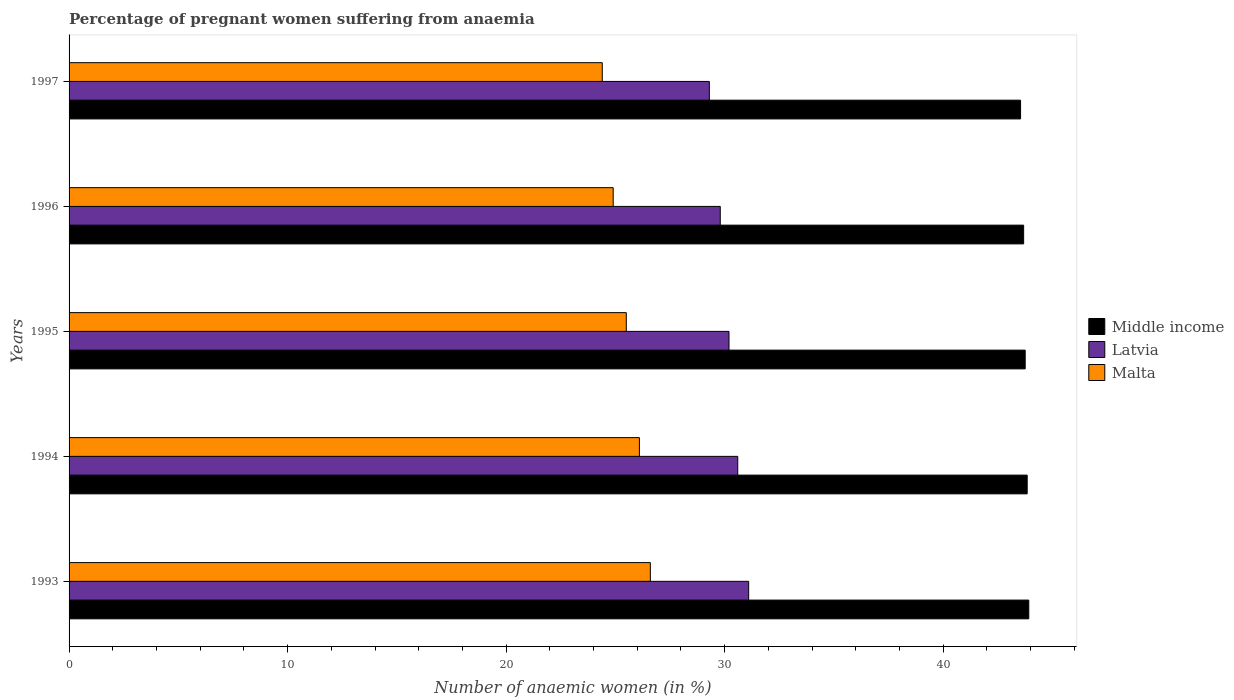How many groups of bars are there?
Ensure brevity in your answer.  5. Are the number of bars per tick equal to the number of legend labels?
Offer a terse response. Yes. How many bars are there on the 3rd tick from the bottom?
Provide a short and direct response. 3. What is the label of the 3rd group of bars from the top?
Your response must be concise. 1995. In how many cases, is the number of bars for a given year not equal to the number of legend labels?
Make the answer very short. 0. What is the number of anaemic women in Malta in 1997?
Offer a terse response. 24.4. Across all years, what is the maximum number of anaemic women in Malta?
Your response must be concise. 26.6. Across all years, what is the minimum number of anaemic women in Latvia?
Your answer should be very brief. 29.3. In which year was the number of anaemic women in Malta maximum?
Provide a short and direct response. 1993. In which year was the number of anaemic women in Malta minimum?
Provide a short and direct response. 1997. What is the total number of anaemic women in Latvia in the graph?
Your response must be concise. 151. What is the difference between the number of anaemic women in Malta in 1993 and that in 1997?
Offer a very short reply. 2.2. What is the difference between the number of anaemic women in Malta in 1996 and the number of anaemic women in Latvia in 1997?
Your answer should be very brief. -4.4. In the year 1997, what is the difference between the number of anaemic women in Latvia and number of anaemic women in Middle income?
Ensure brevity in your answer.  -14.24. What is the ratio of the number of anaemic women in Middle income in 1995 to that in 1996?
Offer a very short reply. 1. Is the number of anaemic women in Latvia in 1994 less than that in 1997?
Ensure brevity in your answer.  No. What is the difference between the highest and the lowest number of anaemic women in Latvia?
Your answer should be very brief. 1.8. What does the 2nd bar from the top in 1993 represents?
Give a very brief answer. Latvia. What does the 2nd bar from the bottom in 1994 represents?
Keep it short and to the point. Latvia. Is it the case that in every year, the sum of the number of anaemic women in Middle income and number of anaemic women in Latvia is greater than the number of anaemic women in Malta?
Give a very brief answer. Yes. How many bars are there?
Your response must be concise. 15. Are all the bars in the graph horizontal?
Provide a succinct answer. Yes. How many years are there in the graph?
Your answer should be compact. 5. Are the values on the major ticks of X-axis written in scientific E-notation?
Ensure brevity in your answer.  No. How are the legend labels stacked?
Provide a succinct answer. Vertical. What is the title of the graph?
Keep it short and to the point. Percentage of pregnant women suffering from anaemia. What is the label or title of the X-axis?
Offer a very short reply. Number of anaemic women (in %). What is the Number of anaemic women (in %) in Middle income in 1993?
Your response must be concise. 43.92. What is the Number of anaemic women (in %) of Latvia in 1993?
Provide a short and direct response. 31.1. What is the Number of anaemic women (in %) of Malta in 1993?
Make the answer very short. 26.6. What is the Number of anaemic women (in %) in Middle income in 1994?
Give a very brief answer. 43.85. What is the Number of anaemic women (in %) in Latvia in 1994?
Your response must be concise. 30.6. What is the Number of anaemic women (in %) in Malta in 1994?
Offer a very short reply. 26.1. What is the Number of anaemic women (in %) in Middle income in 1995?
Provide a short and direct response. 43.75. What is the Number of anaemic women (in %) in Latvia in 1995?
Your answer should be compact. 30.2. What is the Number of anaemic women (in %) of Malta in 1995?
Your answer should be very brief. 25.5. What is the Number of anaemic women (in %) in Middle income in 1996?
Offer a very short reply. 43.68. What is the Number of anaemic women (in %) in Latvia in 1996?
Ensure brevity in your answer.  29.8. What is the Number of anaemic women (in %) in Malta in 1996?
Your answer should be very brief. 24.9. What is the Number of anaemic women (in %) in Middle income in 1997?
Ensure brevity in your answer.  43.54. What is the Number of anaemic women (in %) in Latvia in 1997?
Ensure brevity in your answer.  29.3. What is the Number of anaemic women (in %) of Malta in 1997?
Your response must be concise. 24.4. Across all years, what is the maximum Number of anaemic women (in %) of Middle income?
Your response must be concise. 43.92. Across all years, what is the maximum Number of anaemic women (in %) in Latvia?
Your answer should be compact. 31.1. Across all years, what is the maximum Number of anaemic women (in %) of Malta?
Give a very brief answer. 26.6. Across all years, what is the minimum Number of anaemic women (in %) of Middle income?
Provide a short and direct response. 43.54. Across all years, what is the minimum Number of anaemic women (in %) of Latvia?
Your answer should be compact. 29.3. Across all years, what is the minimum Number of anaemic women (in %) of Malta?
Your answer should be compact. 24.4. What is the total Number of anaemic women (in %) in Middle income in the graph?
Your response must be concise. 218.74. What is the total Number of anaemic women (in %) of Latvia in the graph?
Offer a very short reply. 151. What is the total Number of anaemic women (in %) in Malta in the graph?
Keep it short and to the point. 127.5. What is the difference between the Number of anaemic women (in %) of Middle income in 1993 and that in 1994?
Your answer should be compact. 0.07. What is the difference between the Number of anaemic women (in %) in Latvia in 1993 and that in 1994?
Your answer should be compact. 0.5. What is the difference between the Number of anaemic women (in %) in Malta in 1993 and that in 1994?
Provide a succinct answer. 0.5. What is the difference between the Number of anaemic women (in %) in Middle income in 1993 and that in 1995?
Your answer should be compact. 0.17. What is the difference between the Number of anaemic women (in %) in Latvia in 1993 and that in 1995?
Give a very brief answer. 0.9. What is the difference between the Number of anaemic women (in %) in Middle income in 1993 and that in 1996?
Your answer should be very brief. 0.24. What is the difference between the Number of anaemic women (in %) in Malta in 1993 and that in 1996?
Give a very brief answer. 1.7. What is the difference between the Number of anaemic women (in %) in Middle income in 1993 and that in 1997?
Make the answer very short. 0.38. What is the difference between the Number of anaemic women (in %) in Latvia in 1993 and that in 1997?
Make the answer very short. 1.8. What is the difference between the Number of anaemic women (in %) in Middle income in 1994 and that in 1995?
Provide a succinct answer. 0.09. What is the difference between the Number of anaemic women (in %) in Middle income in 1994 and that in 1996?
Provide a succinct answer. 0.16. What is the difference between the Number of anaemic women (in %) of Malta in 1994 and that in 1996?
Your response must be concise. 1.2. What is the difference between the Number of anaemic women (in %) in Middle income in 1994 and that in 1997?
Give a very brief answer. 0.3. What is the difference between the Number of anaemic women (in %) of Latvia in 1994 and that in 1997?
Your answer should be compact. 1.3. What is the difference between the Number of anaemic women (in %) of Middle income in 1995 and that in 1996?
Your response must be concise. 0.07. What is the difference between the Number of anaemic women (in %) in Latvia in 1995 and that in 1996?
Offer a very short reply. 0.4. What is the difference between the Number of anaemic women (in %) in Malta in 1995 and that in 1996?
Your answer should be compact. 0.6. What is the difference between the Number of anaemic women (in %) in Middle income in 1995 and that in 1997?
Ensure brevity in your answer.  0.21. What is the difference between the Number of anaemic women (in %) in Latvia in 1995 and that in 1997?
Provide a short and direct response. 0.9. What is the difference between the Number of anaemic women (in %) of Malta in 1995 and that in 1997?
Ensure brevity in your answer.  1.1. What is the difference between the Number of anaemic women (in %) in Middle income in 1996 and that in 1997?
Provide a succinct answer. 0.14. What is the difference between the Number of anaemic women (in %) in Latvia in 1996 and that in 1997?
Provide a short and direct response. 0.5. What is the difference between the Number of anaemic women (in %) in Malta in 1996 and that in 1997?
Your response must be concise. 0.5. What is the difference between the Number of anaemic women (in %) in Middle income in 1993 and the Number of anaemic women (in %) in Latvia in 1994?
Ensure brevity in your answer.  13.32. What is the difference between the Number of anaemic women (in %) of Middle income in 1993 and the Number of anaemic women (in %) of Malta in 1994?
Your answer should be very brief. 17.82. What is the difference between the Number of anaemic women (in %) in Latvia in 1993 and the Number of anaemic women (in %) in Malta in 1994?
Provide a succinct answer. 5. What is the difference between the Number of anaemic women (in %) in Middle income in 1993 and the Number of anaemic women (in %) in Latvia in 1995?
Offer a terse response. 13.72. What is the difference between the Number of anaemic women (in %) of Middle income in 1993 and the Number of anaemic women (in %) of Malta in 1995?
Your answer should be compact. 18.42. What is the difference between the Number of anaemic women (in %) of Middle income in 1993 and the Number of anaemic women (in %) of Latvia in 1996?
Offer a terse response. 14.12. What is the difference between the Number of anaemic women (in %) of Middle income in 1993 and the Number of anaemic women (in %) of Malta in 1996?
Provide a succinct answer. 19.02. What is the difference between the Number of anaemic women (in %) of Latvia in 1993 and the Number of anaemic women (in %) of Malta in 1996?
Provide a short and direct response. 6.2. What is the difference between the Number of anaemic women (in %) of Middle income in 1993 and the Number of anaemic women (in %) of Latvia in 1997?
Provide a succinct answer. 14.62. What is the difference between the Number of anaemic women (in %) of Middle income in 1993 and the Number of anaemic women (in %) of Malta in 1997?
Provide a succinct answer. 19.52. What is the difference between the Number of anaemic women (in %) of Middle income in 1994 and the Number of anaemic women (in %) of Latvia in 1995?
Offer a terse response. 13.65. What is the difference between the Number of anaemic women (in %) of Middle income in 1994 and the Number of anaemic women (in %) of Malta in 1995?
Offer a very short reply. 18.35. What is the difference between the Number of anaemic women (in %) in Latvia in 1994 and the Number of anaemic women (in %) in Malta in 1995?
Offer a very short reply. 5.1. What is the difference between the Number of anaemic women (in %) in Middle income in 1994 and the Number of anaemic women (in %) in Latvia in 1996?
Your answer should be compact. 14.05. What is the difference between the Number of anaemic women (in %) in Middle income in 1994 and the Number of anaemic women (in %) in Malta in 1996?
Provide a succinct answer. 18.95. What is the difference between the Number of anaemic women (in %) in Latvia in 1994 and the Number of anaemic women (in %) in Malta in 1996?
Provide a succinct answer. 5.7. What is the difference between the Number of anaemic women (in %) of Middle income in 1994 and the Number of anaemic women (in %) of Latvia in 1997?
Keep it short and to the point. 14.55. What is the difference between the Number of anaemic women (in %) of Middle income in 1994 and the Number of anaemic women (in %) of Malta in 1997?
Make the answer very short. 19.45. What is the difference between the Number of anaemic women (in %) in Middle income in 1995 and the Number of anaemic women (in %) in Latvia in 1996?
Make the answer very short. 13.95. What is the difference between the Number of anaemic women (in %) in Middle income in 1995 and the Number of anaemic women (in %) in Malta in 1996?
Give a very brief answer. 18.85. What is the difference between the Number of anaemic women (in %) in Middle income in 1995 and the Number of anaemic women (in %) in Latvia in 1997?
Your answer should be compact. 14.45. What is the difference between the Number of anaemic women (in %) in Middle income in 1995 and the Number of anaemic women (in %) in Malta in 1997?
Your answer should be very brief. 19.35. What is the difference between the Number of anaemic women (in %) in Latvia in 1995 and the Number of anaemic women (in %) in Malta in 1997?
Provide a short and direct response. 5.8. What is the difference between the Number of anaemic women (in %) of Middle income in 1996 and the Number of anaemic women (in %) of Latvia in 1997?
Make the answer very short. 14.38. What is the difference between the Number of anaemic women (in %) of Middle income in 1996 and the Number of anaemic women (in %) of Malta in 1997?
Give a very brief answer. 19.28. What is the average Number of anaemic women (in %) of Middle income per year?
Offer a terse response. 43.75. What is the average Number of anaemic women (in %) of Latvia per year?
Your answer should be compact. 30.2. What is the average Number of anaemic women (in %) in Malta per year?
Offer a terse response. 25.5. In the year 1993, what is the difference between the Number of anaemic women (in %) of Middle income and Number of anaemic women (in %) of Latvia?
Offer a very short reply. 12.82. In the year 1993, what is the difference between the Number of anaemic women (in %) in Middle income and Number of anaemic women (in %) in Malta?
Provide a succinct answer. 17.32. In the year 1994, what is the difference between the Number of anaemic women (in %) of Middle income and Number of anaemic women (in %) of Latvia?
Make the answer very short. 13.25. In the year 1994, what is the difference between the Number of anaemic women (in %) of Middle income and Number of anaemic women (in %) of Malta?
Provide a short and direct response. 17.75. In the year 1994, what is the difference between the Number of anaemic women (in %) of Latvia and Number of anaemic women (in %) of Malta?
Your response must be concise. 4.5. In the year 1995, what is the difference between the Number of anaemic women (in %) of Middle income and Number of anaemic women (in %) of Latvia?
Your answer should be compact. 13.55. In the year 1995, what is the difference between the Number of anaemic women (in %) of Middle income and Number of anaemic women (in %) of Malta?
Keep it short and to the point. 18.25. In the year 1995, what is the difference between the Number of anaemic women (in %) in Latvia and Number of anaemic women (in %) in Malta?
Your response must be concise. 4.7. In the year 1996, what is the difference between the Number of anaemic women (in %) of Middle income and Number of anaemic women (in %) of Latvia?
Provide a succinct answer. 13.88. In the year 1996, what is the difference between the Number of anaemic women (in %) in Middle income and Number of anaemic women (in %) in Malta?
Your response must be concise. 18.78. In the year 1996, what is the difference between the Number of anaemic women (in %) in Latvia and Number of anaemic women (in %) in Malta?
Make the answer very short. 4.9. In the year 1997, what is the difference between the Number of anaemic women (in %) in Middle income and Number of anaemic women (in %) in Latvia?
Provide a short and direct response. 14.24. In the year 1997, what is the difference between the Number of anaemic women (in %) of Middle income and Number of anaemic women (in %) of Malta?
Ensure brevity in your answer.  19.14. What is the ratio of the Number of anaemic women (in %) in Latvia in 1993 to that in 1994?
Make the answer very short. 1.02. What is the ratio of the Number of anaemic women (in %) in Malta in 1993 to that in 1994?
Give a very brief answer. 1.02. What is the ratio of the Number of anaemic women (in %) in Middle income in 1993 to that in 1995?
Ensure brevity in your answer.  1. What is the ratio of the Number of anaemic women (in %) of Latvia in 1993 to that in 1995?
Give a very brief answer. 1.03. What is the ratio of the Number of anaemic women (in %) of Malta in 1993 to that in 1995?
Your answer should be very brief. 1.04. What is the ratio of the Number of anaemic women (in %) of Middle income in 1993 to that in 1996?
Keep it short and to the point. 1.01. What is the ratio of the Number of anaemic women (in %) in Latvia in 1993 to that in 1996?
Offer a very short reply. 1.04. What is the ratio of the Number of anaemic women (in %) of Malta in 1993 to that in 1996?
Keep it short and to the point. 1.07. What is the ratio of the Number of anaemic women (in %) in Middle income in 1993 to that in 1997?
Ensure brevity in your answer.  1.01. What is the ratio of the Number of anaemic women (in %) of Latvia in 1993 to that in 1997?
Provide a succinct answer. 1.06. What is the ratio of the Number of anaemic women (in %) of Malta in 1993 to that in 1997?
Your response must be concise. 1.09. What is the ratio of the Number of anaemic women (in %) in Latvia in 1994 to that in 1995?
Your response must be concise. 1.01. What is the ratio of the Number of anaemic women (in %) in Malta in 1994 to that in 1995?
Your answer should be very brief. 1.02. What is the ratio of the Number of anaemic women (in %) in Latvia in 1994 to that in 1996?
Offer a terse response. 1.03. What is the ratio of the Number of anaemic women (in %) in Malta in 1994 to that in 1996?
Give a very brief answer. 1.05. What is the ratio of the Number of anaemic women (in %) of Latvia in 1994 to that in 1997?
Ensure brevity in your answer.  1.04. What is the ratio of the Number of anaemic women (in %) in Malta in 1994 to that in 1997?
Provide a succinct answer. 1.07. What is the ratio of the Number of anaemic women (in %) in Middle income in 1995 to that in 1996?
Provide a short and direct response. 1. What is the ratio of the Number of anaemic women (in %) in Latvia in 1995 to that in 1996?
Your response must be concise. 1.01. What is the ratio of the Number of anaemic women (in %) of Malta in 1995 to that in 1996?
Your answer should be compact. 1.02. What is the ratio of the Number of anaemic women (in %) in Middle income in 1995 to that in 1997?
Give a very brief answer. 1. What is the ratio of the Number of anaemic women (in %) in Latvia in 1995 to that in 1997?
Offer a terse response. 1.03. What is the ratio of the Number of anaemic women (in %) of Malta in 1995 to that in 1997?
Offer a very short reply. 1.05. What is the ratio of the Number of anaemic women (in %) in Latvia in 1996 to that in 1997?
Give a very brief answer. 1.02. What is the ratio of the Number of anaemic women (in %) of Malta in 1996 to that in 1997?
Your answer should be very brief. 1.02. What is the difference between the highest and the second highest Number of anaemic women (in %) of Middle income?
Keep it short and to the point. 0.07. What is the difference between the highest and the lowest Number of anaemic women (in %) of Middle income?
Your answer should be very brief. 0.38. What is the difference between the highest and the lowest Number of anaemic women (in %) in Malta?
Your answer should be compact. 2.2. 